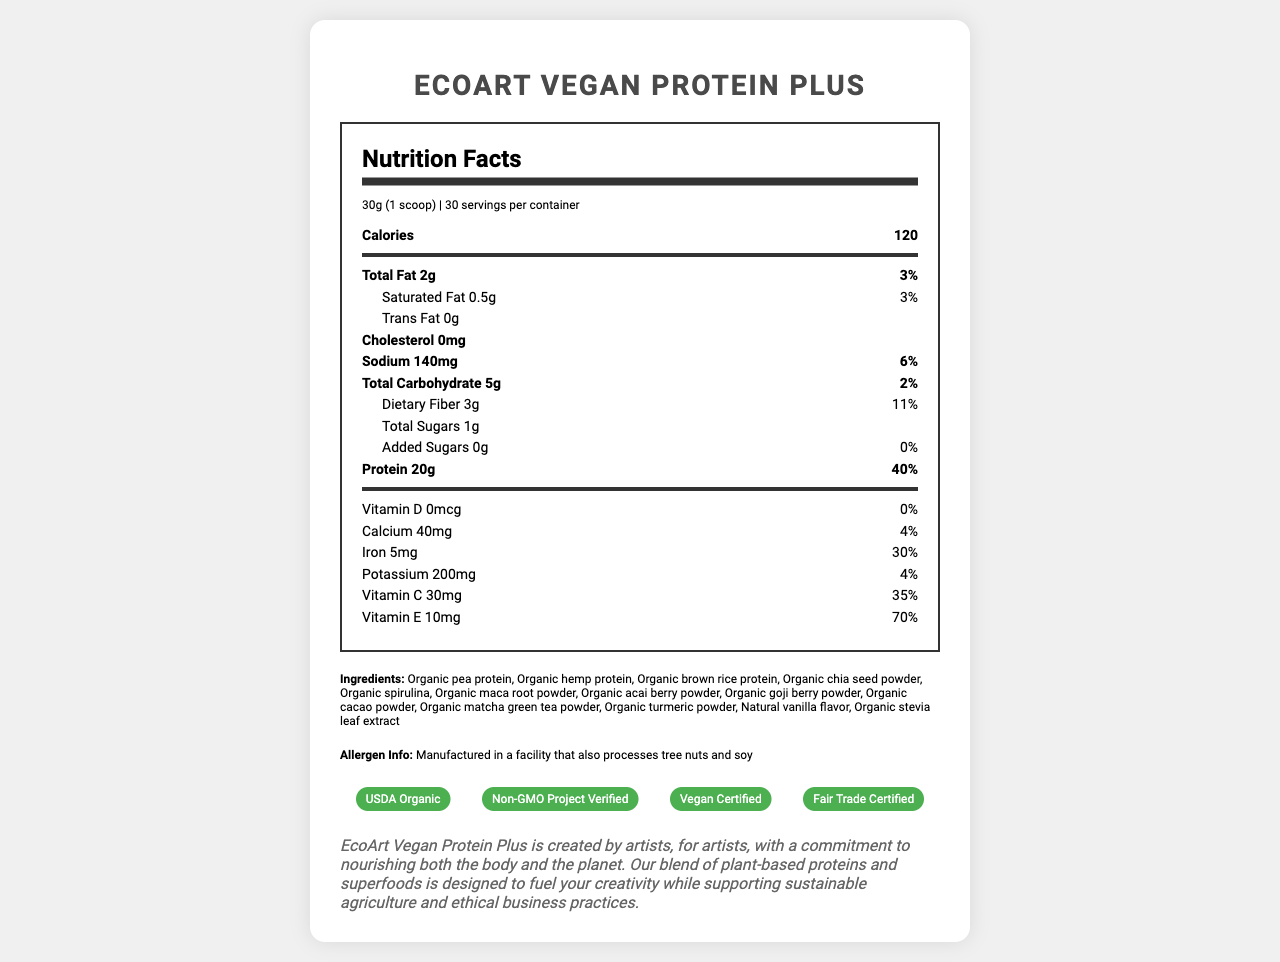what is the serving size? The serving size is listed as "30g (1 scoop)" in the document.
Answer: 30g (1 scoop) how many calories are there per serving? The document states that there are 120 calories per serving.
Answer: 120 what is the amount of protein per serving? The document lists 20g of protein per serving.
Answer: 20g what is the daily value percentage of iron per serving? The iron daily value percentage is 30%, as shown in the nutrition facts.
Answer: 30% what are the main ingredients? The ingredients are listed under the ingredients section in the document.
Answer: Organic pea protein, Organic hemp protein, Organic brown rice protein, Organic chia seed powder, Organic spirulina, Organic maca root powder, Organic acai berry powder, Organic goji berry powder, Organic cacao powder, Organic matcha green tea powder, Organic turmeric powder, Natural vanilla flavor, Organic stevia leaf extract how many servings are there per container? The servings per container are stated as 30.
Answer: 30 what is the total fat content per serving? The total fat per serving is listed as 2g.
Answer: 2g what certifications does the product have? A. USDA Organic B. Non-GMO Project Verified C. Vegan Certified D. Gluten-Free E. Fair Trade Certified The document shows the certifications: USDA Organic, Non-GMO Project Verified, Vegan Certified, and Fair Trade Certified.
Answer: B and D which vitamin has the highest daily value percentage per serving? The daily value percentage for Vitamin E is 70%, which is higher than the other vitamins listed.
Answer: Vitamin E does the product contain any cholesterol? The document states that the cholesterol content is 0mg.
Answer: No is the packaging eco-friendly? The marketing claims section states that the packaging is made from 100% recycled materials.
Answer: Yes summarize the main idea of the document. The document provides detailed nutritional information, ingredients, allergen information, certifications, and brand story emphasizing the product's nutritional benefits and ethical sourcing.
Answer: The EcoArt Vegan Protein Plus is a vegan protein powder with various added superfoods and antioxidants. It contains organic, ethically sourced ingredients and offers comprehensive nutritional benefits, including high protein and essential vitamins. The product supports environmental conservation and sustainable practices. It is certified USDA Organic, Non-GMO Project Verified, Vegan Certified, and Fair Trade Certified. what is the exact percentage of daily value for dietary fiber per serving? The percentage of daily value for dietary fiber is explicitly stated as 11% in the nutrition facts.
Answer: 11% what is the brand story behind the product? The document includes a brand story section that provides this detailed information.
Answer: EcoArt Vegan Protein Plus is created by artists, for artists, with a commitment to nourishing both the body and the planet. Our blend of plant-based proteins and superfoods is designed to fuel your creativity while supporting sustainable agriculture and ethical business practices. what amount of sugar is added to the product? The document specifies that the product contains 0g of added sugars.
Answer: 0g what flavor is included in the product for taste enhancement? The ingredients list shows "Natural vanilla flavor" as one of the components.
Answer: Natural vanilla flavor what is the primary benefit highlighted in the product description? The product description emphasizes that the blend supports artistic endeavors and social change.
Answer: Supports artistic journey and fuels passion for social change where is the product manufactured? The document does not provide information on the manufacturing location, only that it is processed in a facility that also deals with tree nuts and soy.
Answer: Cannot be determined 